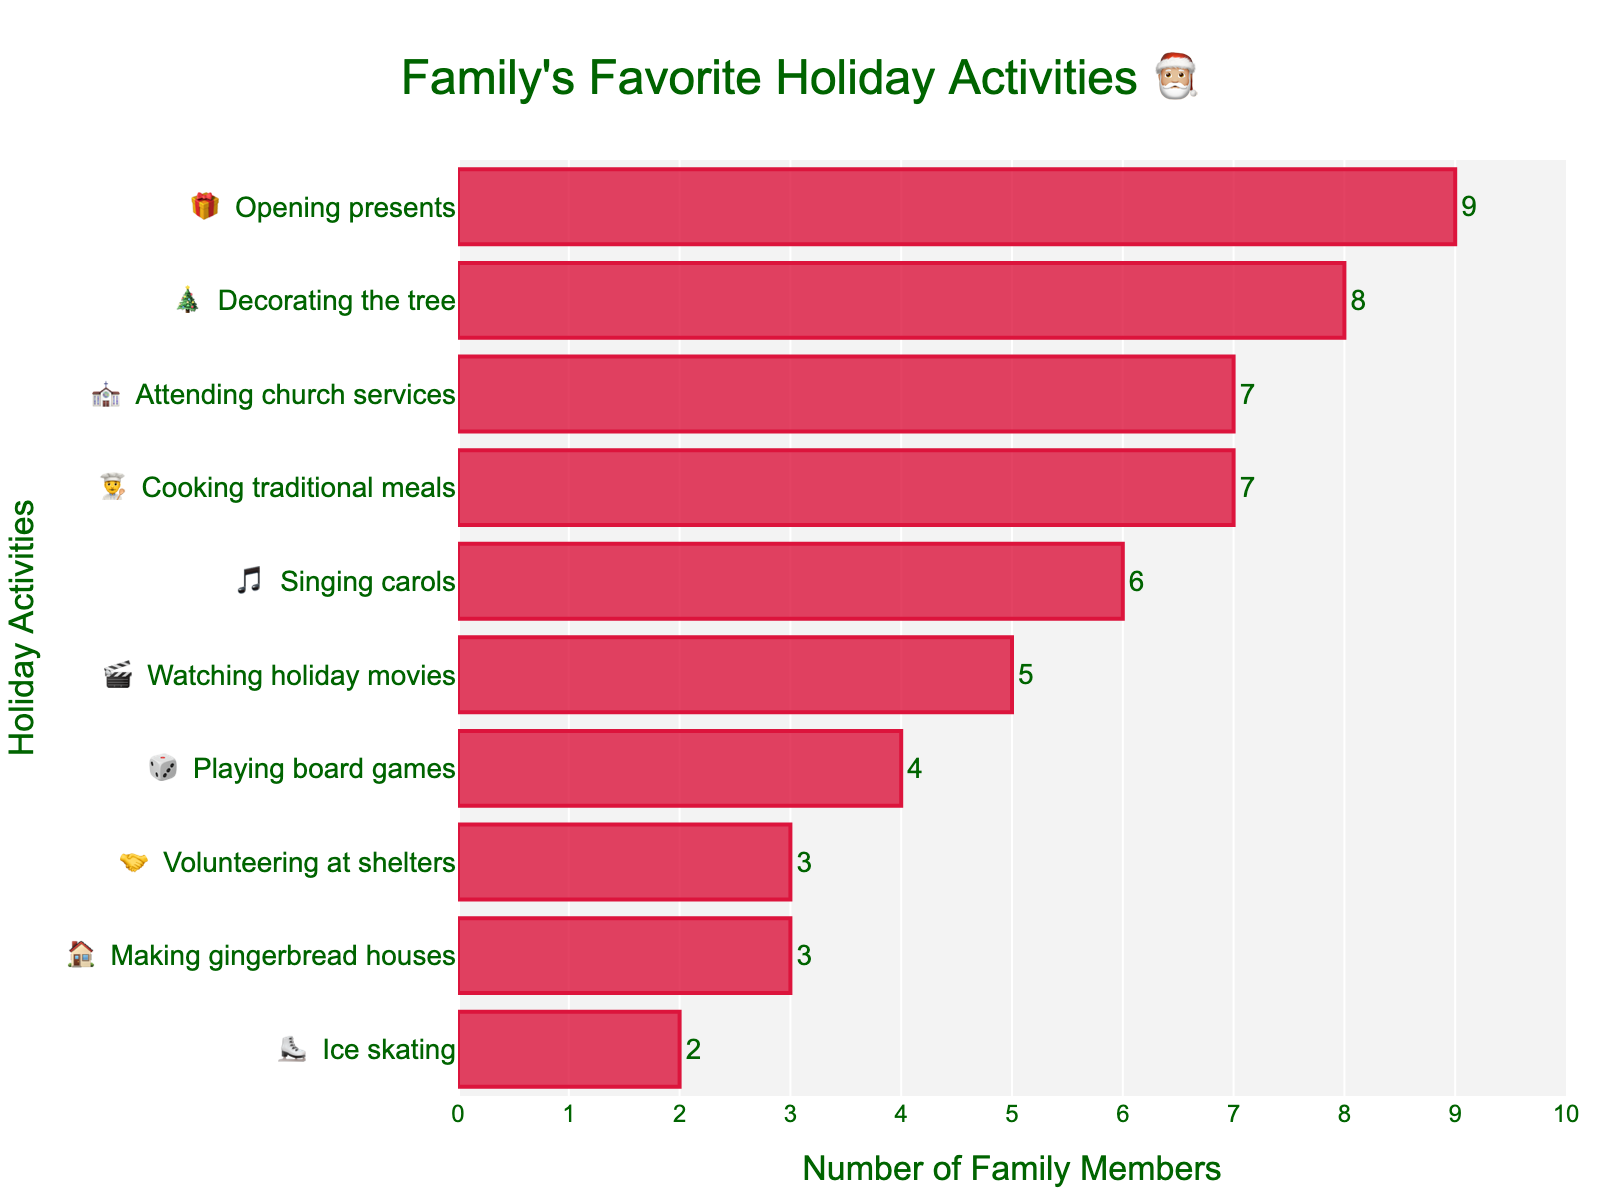What's the favorite holiday activity in the family? The chart shows a horizontal bar graph with various holiday activities listed alongside corresponding emoji. The longest bar represents the favorite activity. From the chart, we see that "Opening presents 🎁" has the longest bar, indicating it is the favorite activity.
Answer: Opening presents How many family members enjoy decorating the tree? The "Decorating the tree 🎄" bar shows the number of family members next to it. According to the chart, 8 family members enjoy this activity.
Answer: 8 What is the least favorite holiday activity in the family? The chart lists activities from least to most favorite in ascending order. The shortest bar indicates the least favorite activity. In this case, "Ice skating ⛸️" has the shortest bar.
Answer: Ice skating How many activities are more popular than cooking traditional meals? First, identify how many family members enjoy cooking traditional meals (7). Then count the number of activities with a higher count. According to the chart, "Decorating the tree," "Opening presents," and "Attending church services" have higher counts. So, 3 activities are more popular.
Answer: 3 What is the combined total of family members who enjoy making gingerbread houses and volunteering at shelters? From the chart, 3 family members enjoy making gingerbread houses, and another 3 enjoy volunteering at shelters. Adding these together gives 3 + 3 = 6.
Answer: 6 Which activity has just one more participant than playing board games? According to the chart, "Playing board games 🎲" has a count of 4. Thus, we look for an activity with a count of 5. "Watching holiday movies 🎬" has 5 participants.
Answer: Watching holiday movies Do more family members enjoy attending church services or singing carols? The "Attending church services ⛪" activity has 7 participants, while the "Singing carols 🎵" activity has 6. Comparing these numbers, more family members enjoy attending church services.
Answer: Attending church services How many activities have fewer than 5 participants? Looking at the counts for each activity on the chart, "Making gingerbread houses 🏠" (3), "Ice skating ⛸️" (2), and "Volunteering at shelters 🤝" (3) have fewer than 5 participants. Therefore, there are 3 activities.
Answer: 3 By how much does the number of family members who enjoy watching holiday movies exceed those who enjoy ice skating? According to the chart, 5 family members enjoy watching holiday movies, and 2 enjoy ice skating. Calculating the difference gives 5 - 2 = 3.
Answer: 3 What's the difference in popularity between the most and least popular activities? The most popular activity "Opening presents 🎁" has 9 participants, while the least popular "Ice skating ⛸️" has 2. Subtracting these two gives 9 - 2 = 7.
Answer: 7 